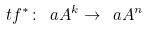<formula> <loc_0><loc_0><loc_500><loc_500>\ t f ^ { * } \colon \ a A ^ { k } \to \ a A ^ { n }</formula> 